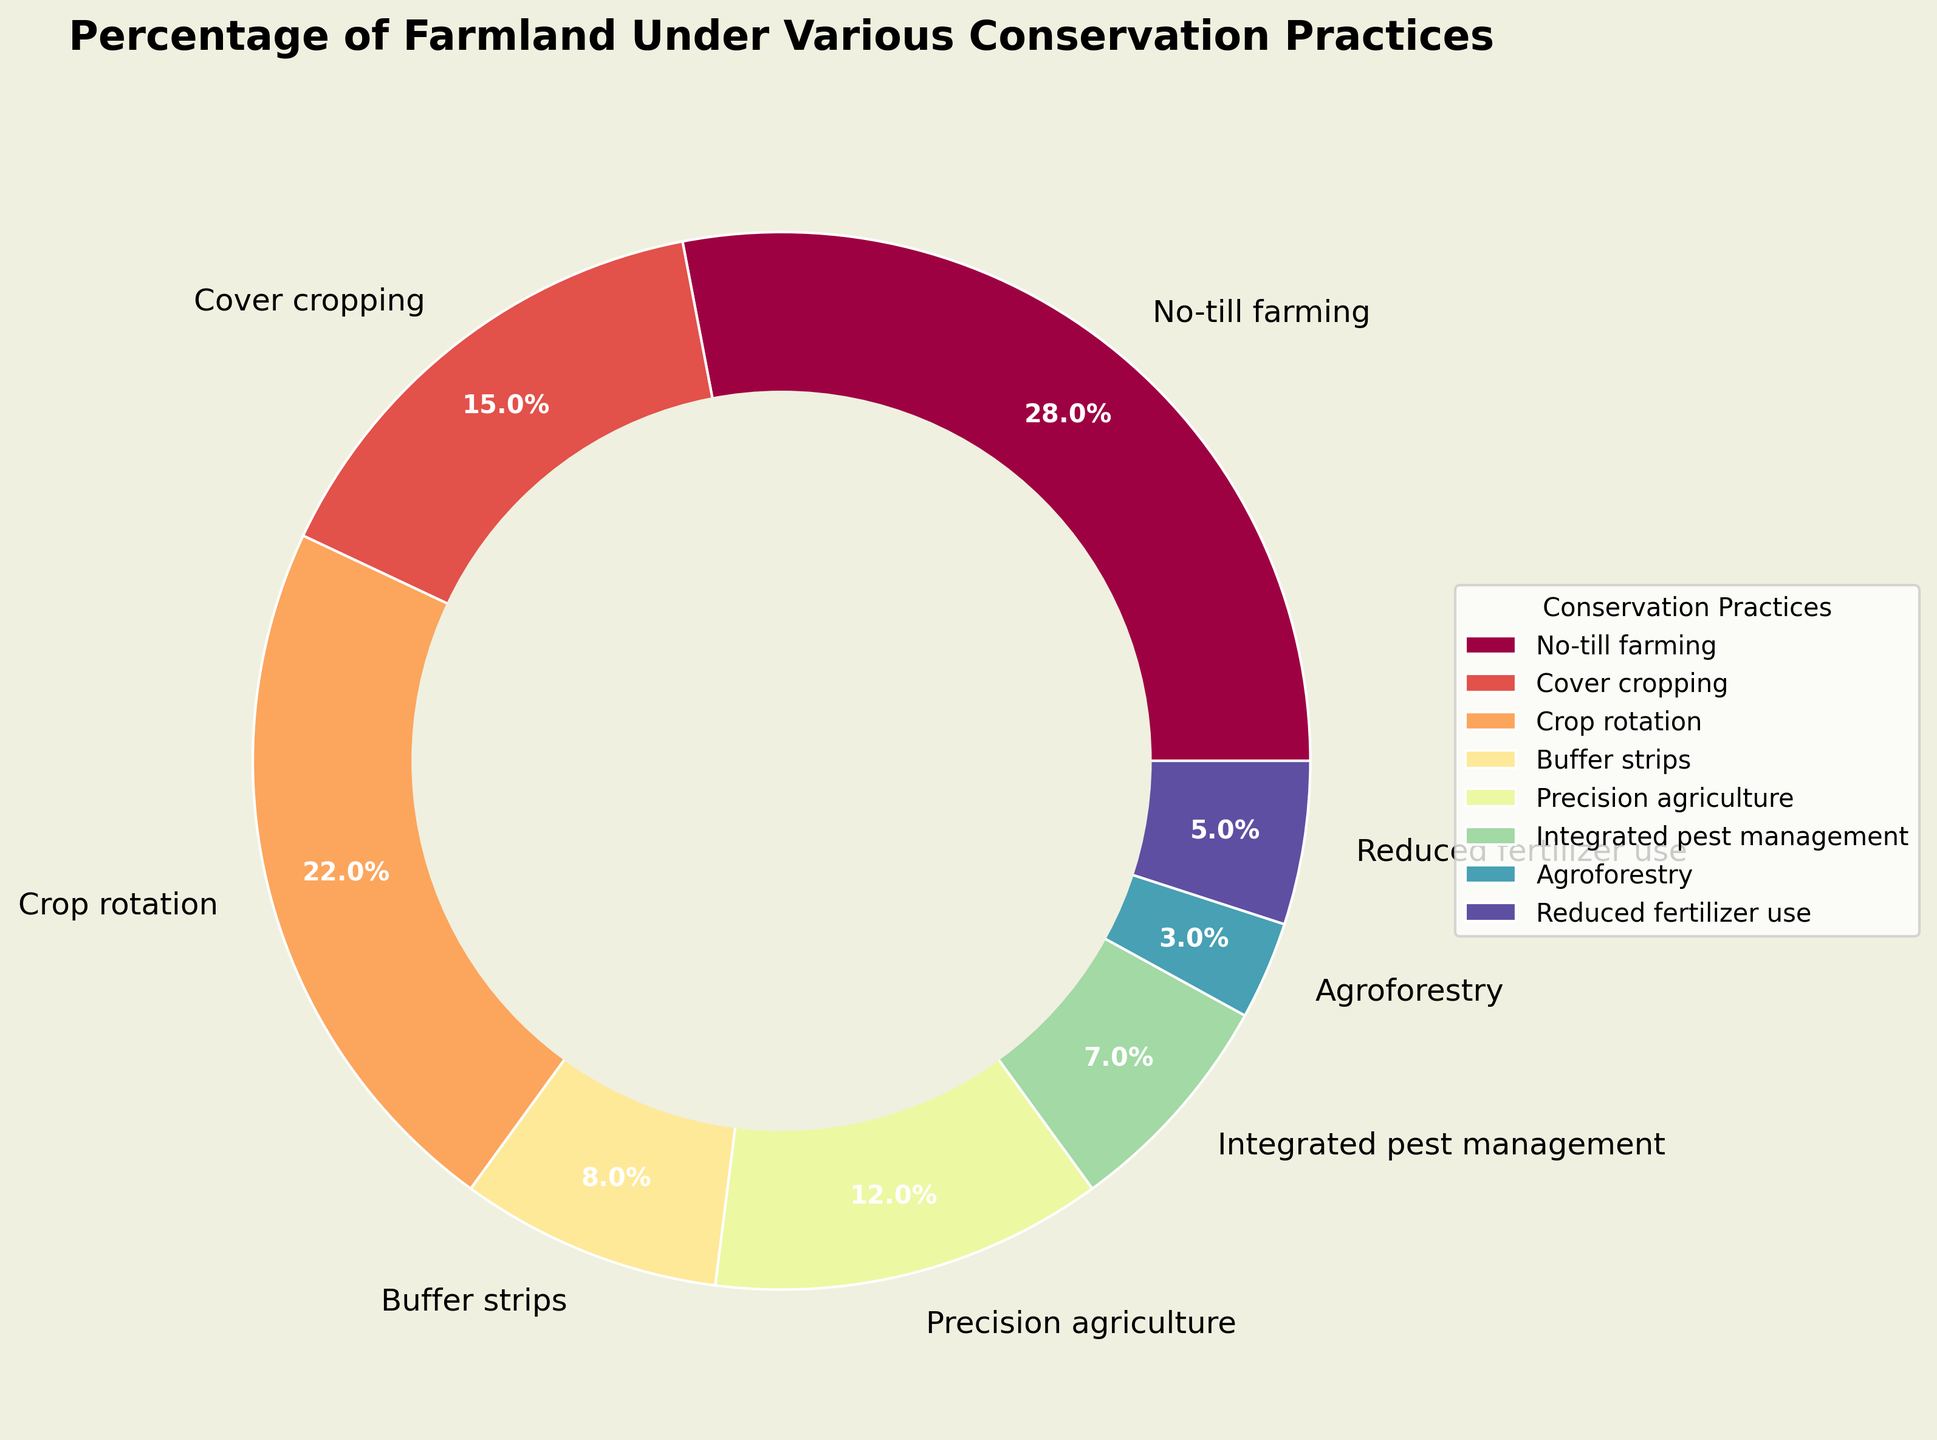What's the combined percentage of farmland under No-till farming and Cover cropping? To find the combined percentage, add the percentages of No-till farming and Cover cropping: 28% + 15% = 43%.
Answer: 43% Which conservation practice occupies the smallest percentage of farmland? Look at the pie chart and identify the smallest wedge, which corresponds to Agroforestry at 3%.
Answer: Agroforestry Is No-till farming more than twice as common as Reduced fertilizer use? Compare the percentages: No-till farming is 28% and Reduced fertilizer use is 5%. Check if 28% is more than 2 times 5%. 2 * 5% = 10%, and since 28% > 10%, the answer is yes.
Answer: Yes What percentage of farmland is covered by practices other than No-till farming, Cover cropping, and Crop rotation? Subtract the combined percentage of No-till farming, Cover cropping, and Crop rotation from 100%: 28% + 15% + 22% = 65%. Thus, the remaining percentage is 100% - 65% = 35%.
Answer: 35% Which conservation practice has a percentage closest to that of Precision agriculture? Looking at the pie chart, compare other practices' percentages to 12% (Precision agriculture). Integrated pest management at 7% is the closest.
Answer: Integrated pest management How many practices have more than 10% of farmland under them? Identify the practices with percentages more than 10%: No-till farming (28%), Cover cropping (15%), Crop rotation (22%), and Precision agriculture (12%). This counts to 4.
Answer: 4 Is the percentage of farmland under Buffer strips and Agroforestry combined greater than that under Integrated pest management? Add the percentages of Buffer strips (8%) and Agroforestry (3%): 8% + 3% = 11%, which is greater than Integrated pest management (7%).
Answer: Yes What's the average percentage of farmland under the conservation practices except No-till farming? Exclude No-till farming’s percentage and sum up the others: 15% + 22% + 8% + 12% + 7% + 3% + 5% = 72%. There are 7 practices, so the average is 72% / 7 ≈ 10.29%.
Answer: 10.29% Which conservation practice has a wedge closest to the color green? Without visualizing the exact colors, analyze spectra colors generally. Green is usually somewhere in the midway of a spectrum colormap. Precision agriculture, being somewhat in the middle (12%), might be closer to green.
Answer: Precision agriculture 